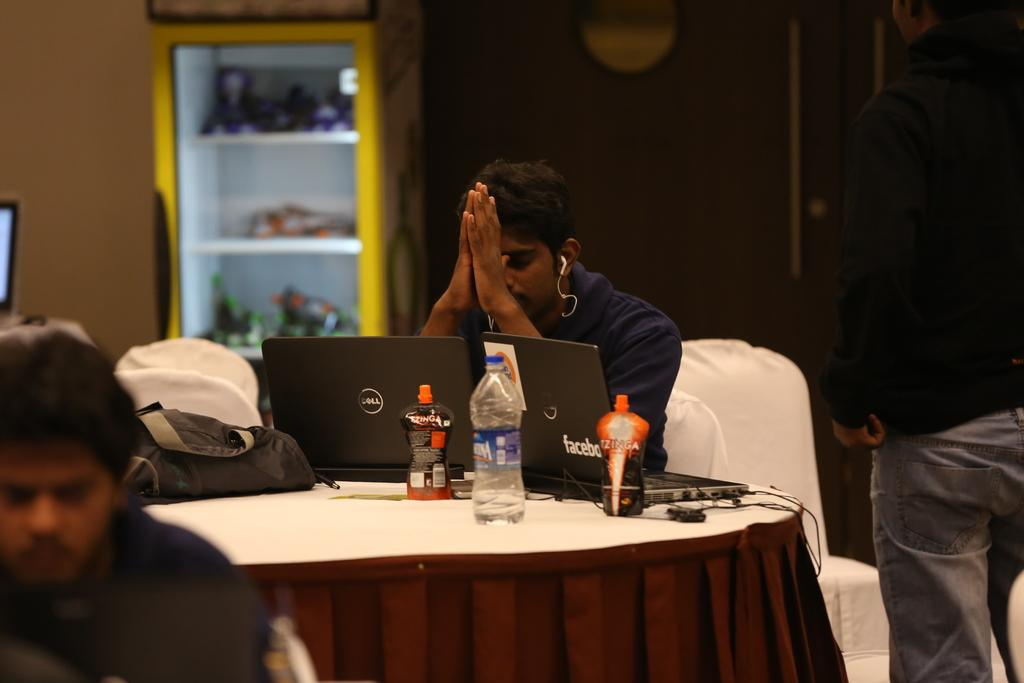What is the main subject of the image? There is a guy in the image. What is the guy doing in the image? The guy is sitting on a table. What objects are in front of the guy? There are laptops in front of the guy. What is the guy wearing on his head? The guy is wearing a headphone. What can be seen in the background of the image? There is a refrigerator in the background of the image. What is inside the refrigerator? The refrigerator is filled with bottles. What type of noise can be heard coming from the guy's headphone in the image? There is no indication in the image of the type of noise coming from the guy's headphone, as the image is silent. 